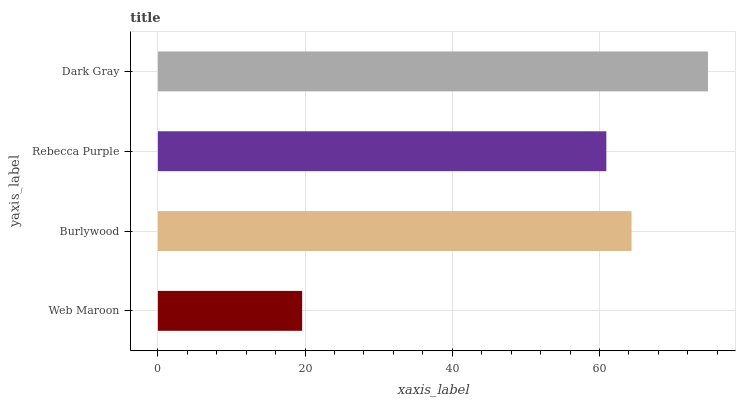Is Web Maroon the minimum?
Answer yes or no. Yes. Is Dark Gray the maximum?
Answer yes or no. Yes. Is Burlywood the minimum?
Answer yes or no. No. Is Burlywood the maximum?
Answer yes or no. No. Is Burlywood greater than Web Maroon?
Answer yes or no. Yes. Is Web Maroon less than Burlywood?
Answer yes or no. Yes. Is Web Maroon greater than Burlywood?
Answer yes or no. No. Is Burlywood less than Web Maroon?
Answer yes or no. No. Is Burlywood the high median?
Answer yes or no. Yes. Is Rebecca Purple the low median?
Answer yes or no. Yes. Is Dark Gray the high median?
Answer yes or no. No. Is Dark Gray the low median?
Answer yes or no. No. 